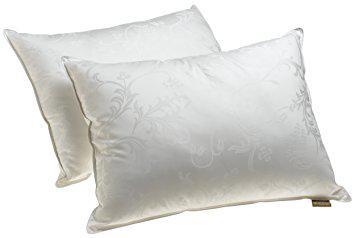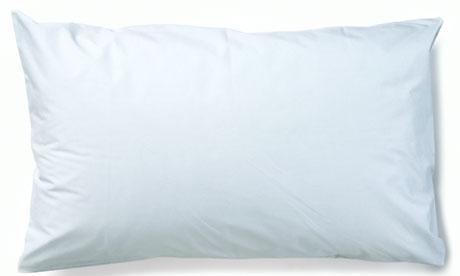The first image is the image on the left, the second image is the image on the right. For the images displayed, is the sentence "Each image contains two pillows, and all pillows are rectangular rather than square." factually correct? Answer yes or no. No. The first image is the image on the left, the second image is the image on the right. Considering the images on both sides, is "One of the images has fewer than two pillows." valid? Answer yes or no. Yes. 